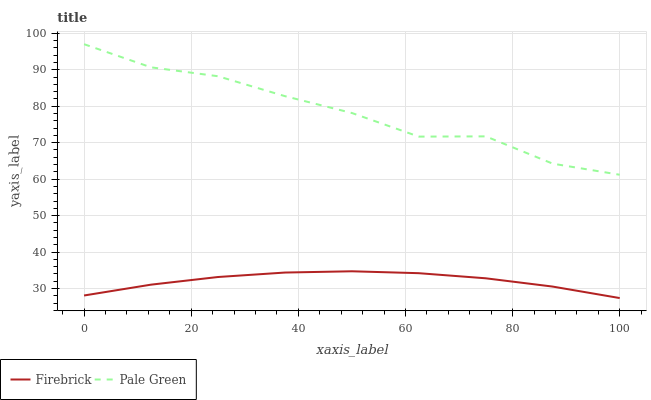Does Firebrick have the minimum area under the curve?
Answer yes or no. Yes. Does Pale Green have the maximum area under the curve?
Answer yes or no. Yes. Does Pale Green have the minimum area under the curve?
Answer yes or no. No. Is Firebrick the smoothest?
Answer yes or no. Yes. Is Pale Green the roughest?
Answer yes or no. Yes. Is Pale Green the smoothest?
Answer yes or no. No. Does Firebrick have the lowest value?
Answer yes or no. Yes. Does Pale Green have the lowest value?
Answer yes or no. No. Does Pale Green have the highest value?
Answer yes or no. Yes. Is Firebrick less than Pale Green?
Answer yes or no. Yes. Is Pale Green greater than Firebrick?
Answer yes or no. Yes. Does Firebrick intersect Pale Green?
Answer yes or no. No. 